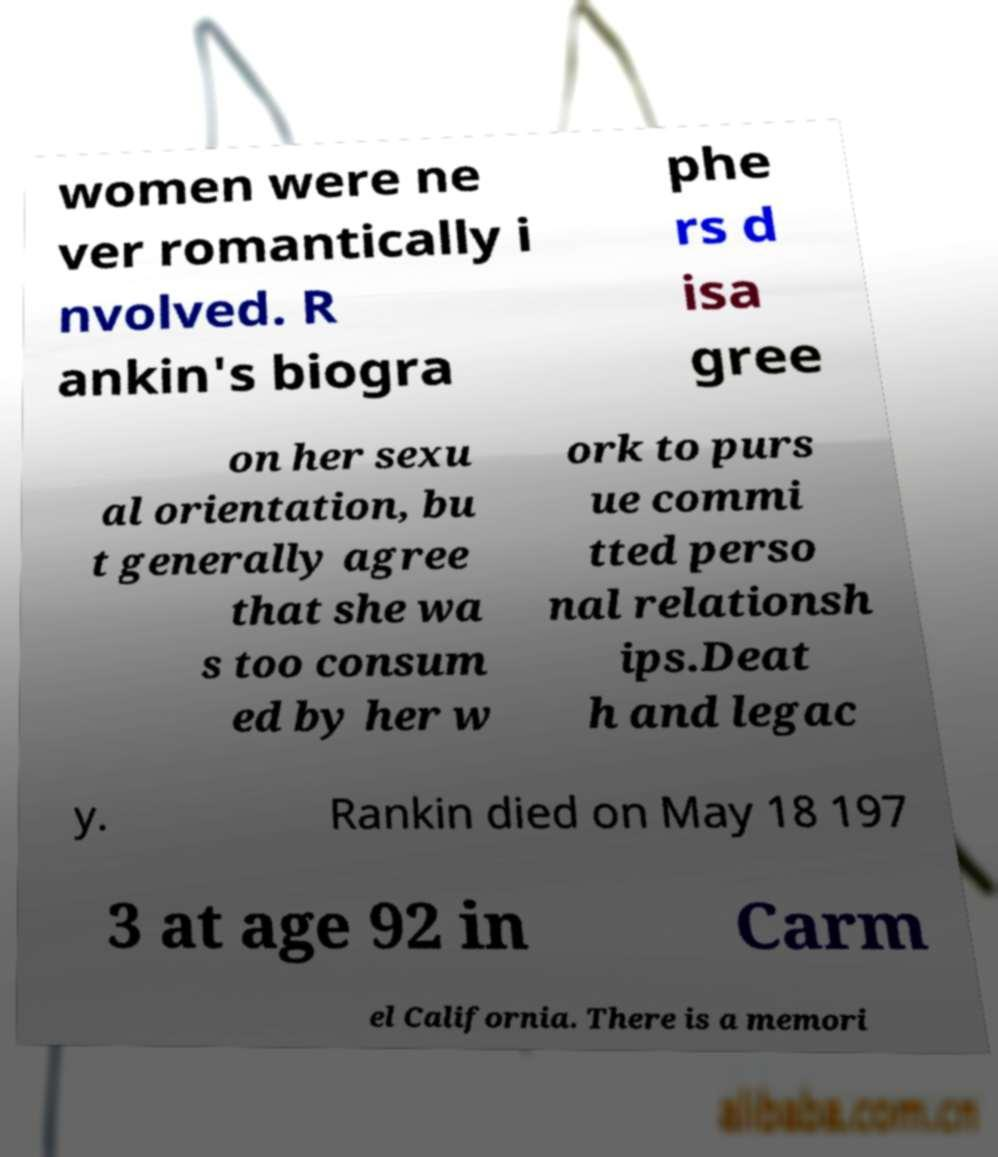For documentation purposes, I need the text within this image transcribed. Could you provide that? women were ne ver romantically i nvolved. R ankin's biogra phe rs d isa gree on her sexu al orientation, bu t generally agree that she wa s too consum ed by her w ork to purs ue commi tted perso nal relationsh ips.Deat h and legac y. Rankin died on May 18 197 3 at age 92 in Carm el California. There is a memori 